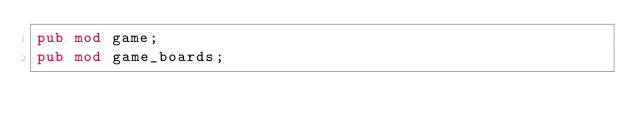Convert code to text. <code><loc_0><loc_0><loc_500><loc_500><_Rust_>pub mod game;
pub mod game_boards;</code> 